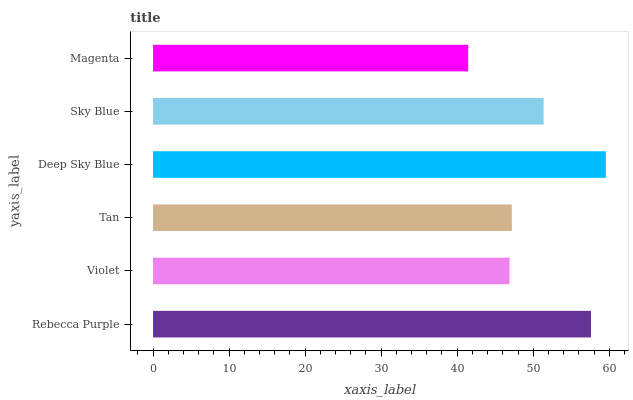Is Magenta the minimum?
Answer yes or no. Yes. Is Deep Sky Blue the maximum?
Answer yes or no. Yes. Is Violet the minimum?
Answer yes or no. No. Is Violet the maximum?
Answer yes or no. No. Is Rebecca Purple greater than Violet?
Answer yes or no. Yes. Is Violet less than Rebecca Purple?
Answer yes or no. Yes. Is Violet greater than Rebecca Purple?
Answer yes or no. No. Is Rebecca Purple less than Violet?
Answer yes or no. No. Is Sky Blue the high median?
Answer yes or no. Yes. Is Tan the low median?
Answer yes or no. Yes. Is Magenta the high median?
Answer yes or no. No. Is Violet the low median?
Answer yes or no. No. 